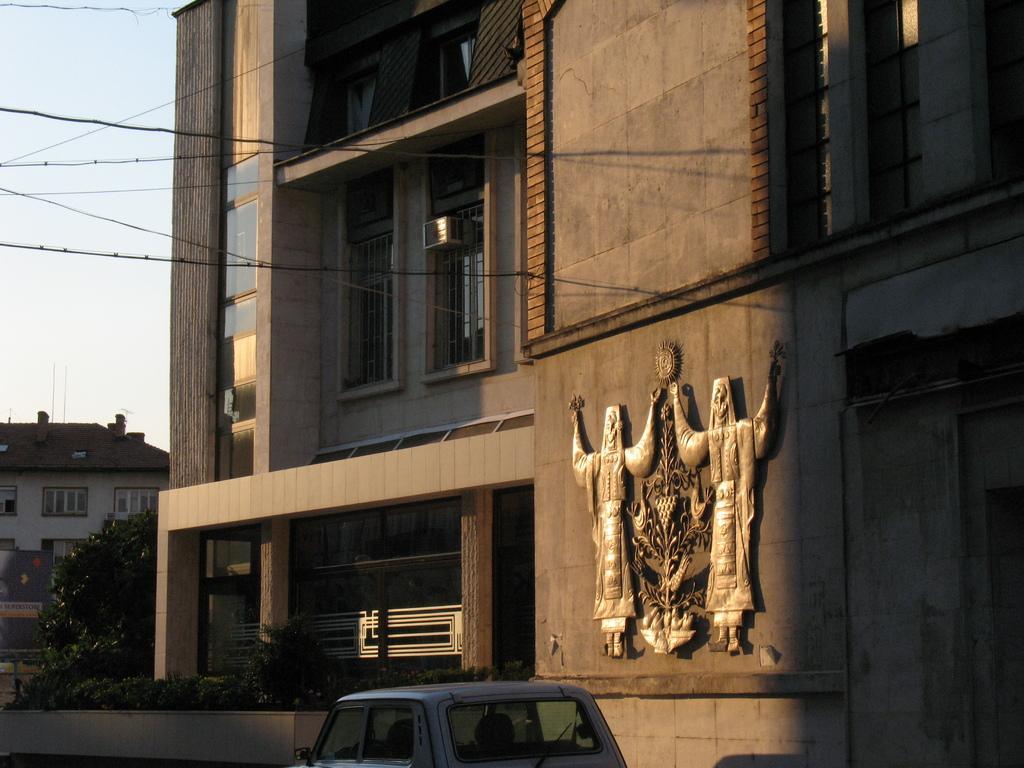Please provide a concise description of this image. In this picture we can see few buildings and a car on the road, beside to the building we can find few trees and cables. 